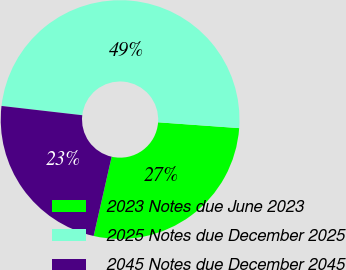Convert chart. <chart><loc_0><loc_0><loc_500><loc_500><pie_chart><fcel>2023 Notes due June 2023<fcel>2025 Notes due December 2025<fcel>2045 Notes due December 2045<nl><fcel>27.42%<fcel>49.32%<fcel>23.26%<nl></chart> 